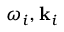Convert formula to latex. <formula><loc_0><loc_0><loc_500><loc_500>\omega _ { i } , k _ { i }</formula> 